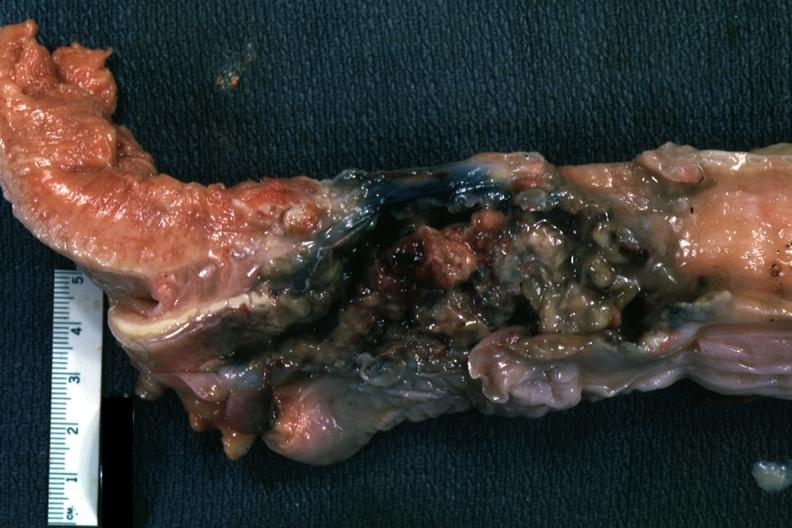how is larynx mass of tissue?
Answer the question using a single word or phrase. Necrotic 